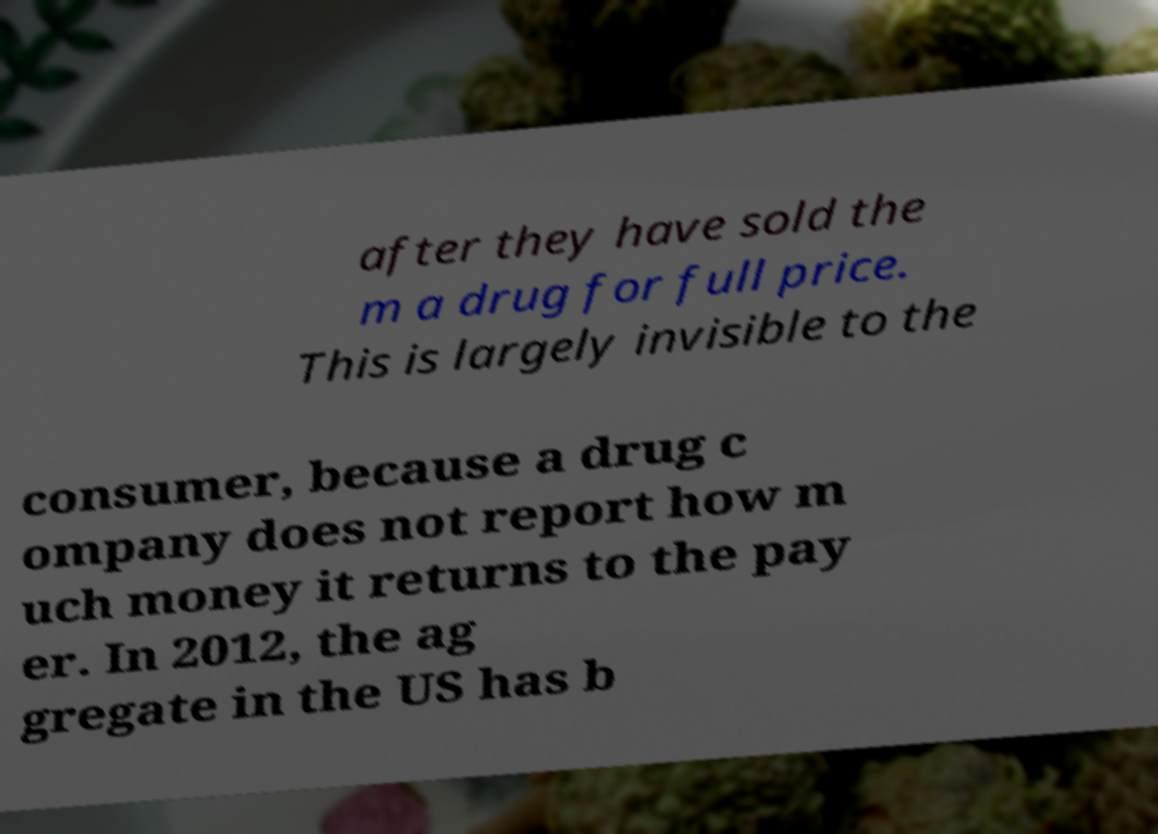There's text embedded in this image that I need extracted. Can you transcribe it verbatim? after they have sold the m a drug for full price. This is largely invisible to the consumer, because a drug c ompany does not report how m uch money it returns to the pay er. In 2012, the ag gregate in the US has b 